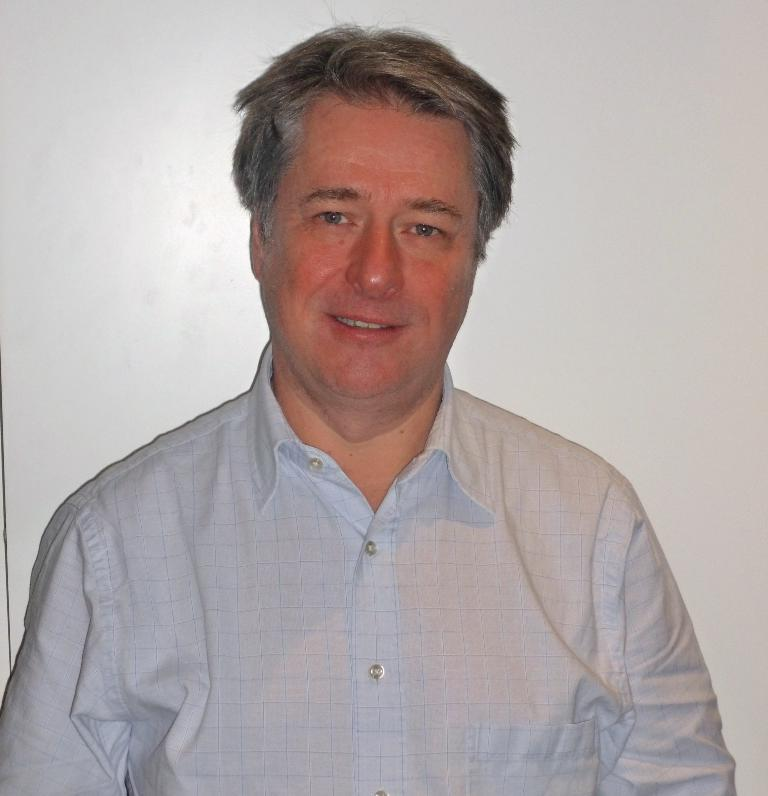What is the main subject of the image? There is a person in the image. What can be observed about the person's attire? The person is wearing clothes. What is the color of the background in the image? The background of the image is white. What type of beef is being served in the image? There is no beef present in the image; it features a person with a white background. 